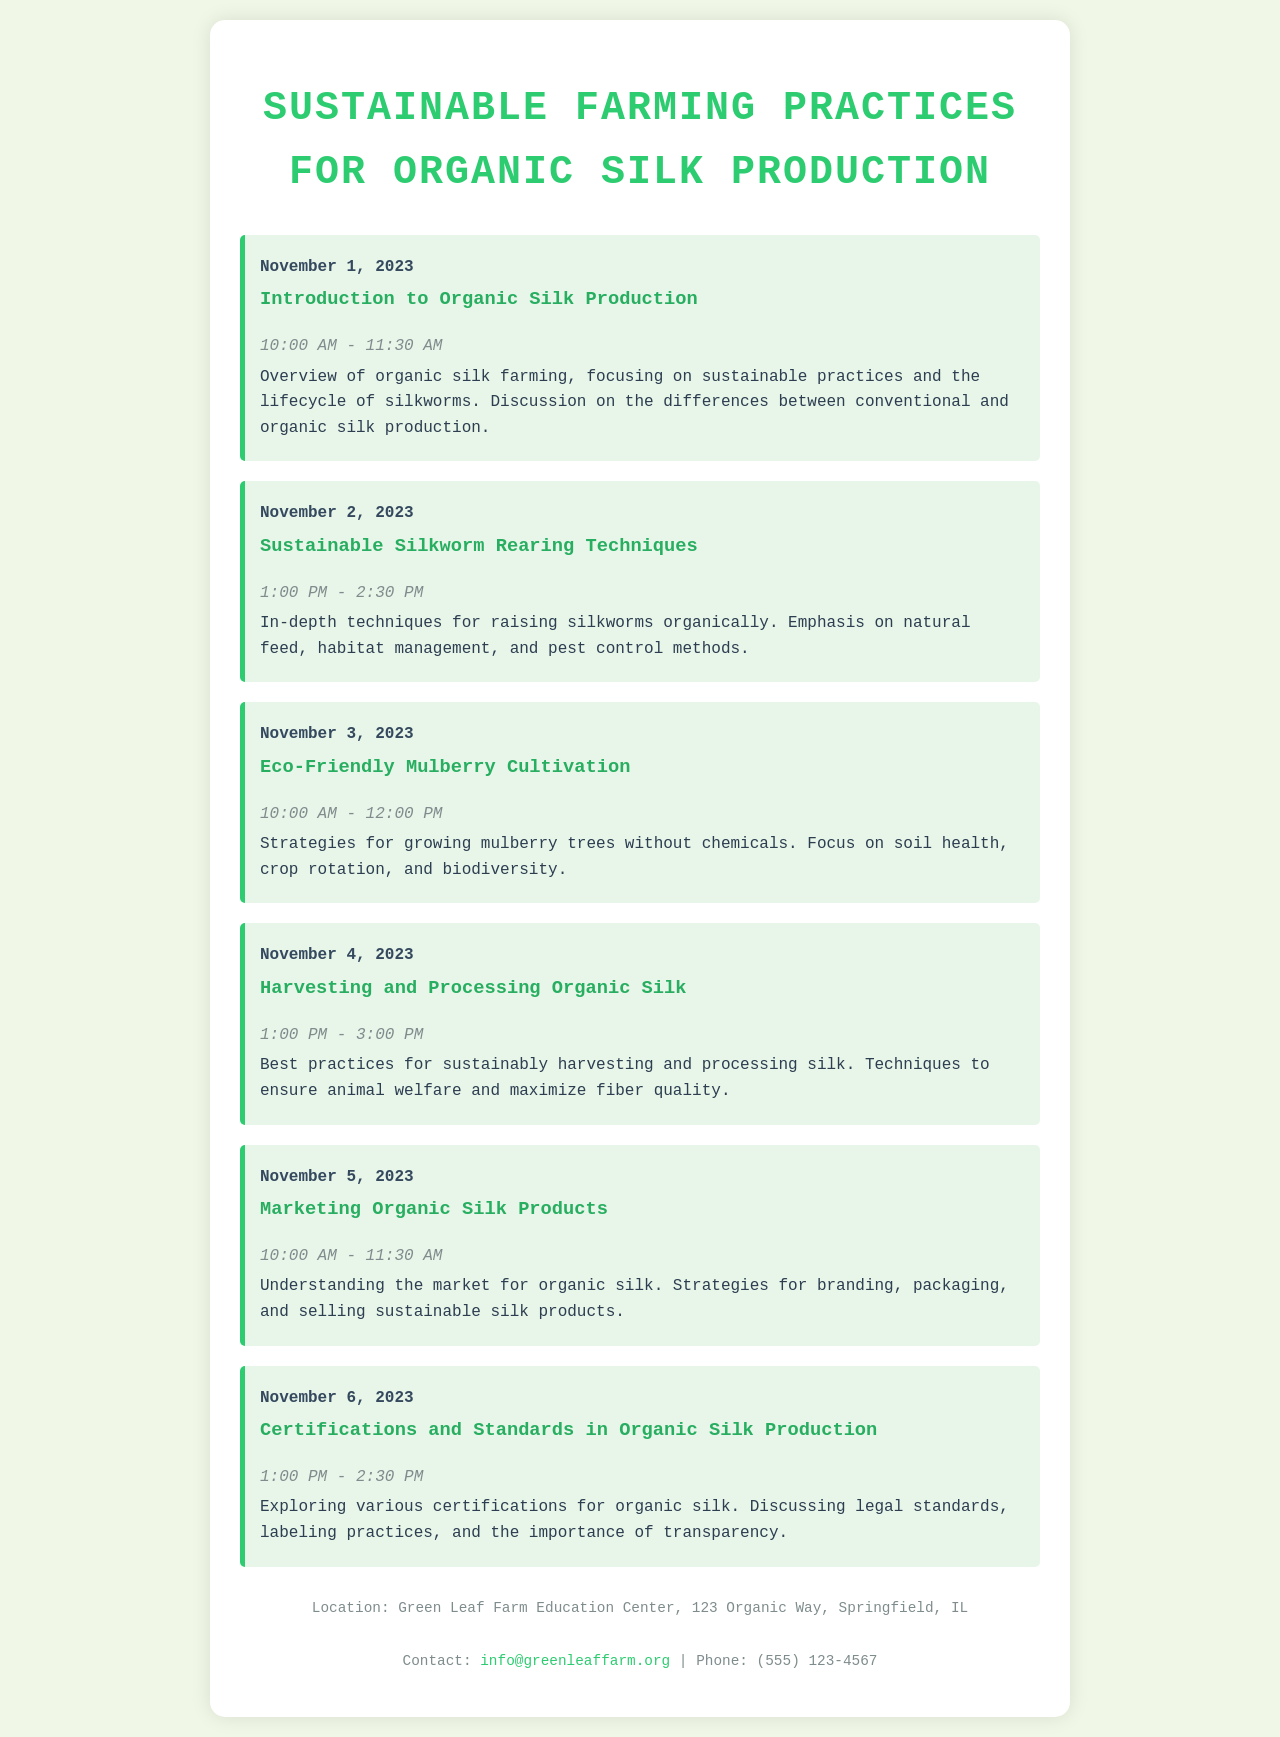What is the title of the workshop? The title can be found at the top of the document, summarizing the purpose of the event.
Answer: Sustainable Farming Practices for Organic Silk Production When does the session on Eco-Friendly Mulberry Cultivation take place? The date of the Eco-Friendly Mulberry Cultivation session is specified within the session details.
Answer: November 3, 2023 What time does the Introduction to Organic Silk Production start? The start time for the session is mentioned alongside the date for that session.
Answer: 10:00 AM How many sessions are scheduled in total? The number of sessions can be counted from the list provided in the document.
Answer: 6 What is the focus of the session on Harvesting and Processing Organic Silk? The details of the session describe its main topic and purpose.
Answer: Best practices for sustainably harvesting and processing silk What location is indicated for the workshop? The workshop's location is noted at the bottom of the document.
Answer: Green Leaf Farm Education Center, 123 Organic Way, Springfield, IL Which session discusses marketing strategies for organic silk products? The title of the marketing session is given in the workshop schedule.
Answer: Marketing Organic Silk Products What is the duration of the session on Certifications and Standards in Organic Silk Production? The time window for the session is noted alongside its date and title.
Answer: 1:00 PM - 2:30 PM What email address is provided for contact? The contact information includes an email address listed for inquiries.
Answer: info@greenleaffarm.org 